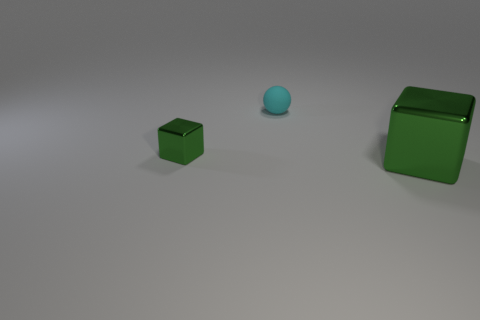Add 1 big green metal cubes. How many objects exist? 4 Subtract all spheres. How many objects are left? 2 Add 3 small things. How many small things exist? 5 Subtract 0 purple blocks. How many objects are left? 3 Subtract all large green shiny cubes. Subtract all big green blocks. How many objects are left? 1 Add 1 large green metallic blocks. How many large green metallic blocks are left? 2 